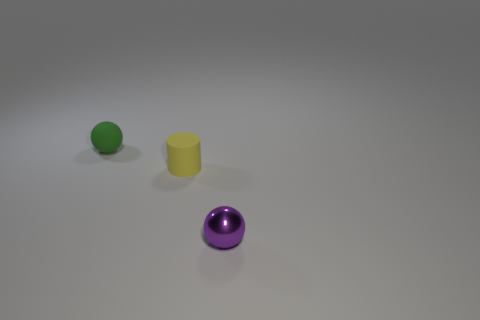Subtract all yellow balls. Subtract all blue cylinders. How many balls are left? 2 Subtract all green balls. How many green cylinders are left? 0 Add 2 small purples. How many tiny objects exist? 0 Subtract all cylinders. Subtract all small rubber spheres. How many objects are left? 1 Add 1 purple objects. How many purple objects are left? 2 Add 2 purple matte things. How many purple matte things exist? 2 Add 2 green cubes. How many objects exist? 5 Subtract all purple spheres. How many spheres are left? 1 Subtract 0 brown cylinders. How many objects are left? 3 Subtract all cylinders. How many objects are left? 2 